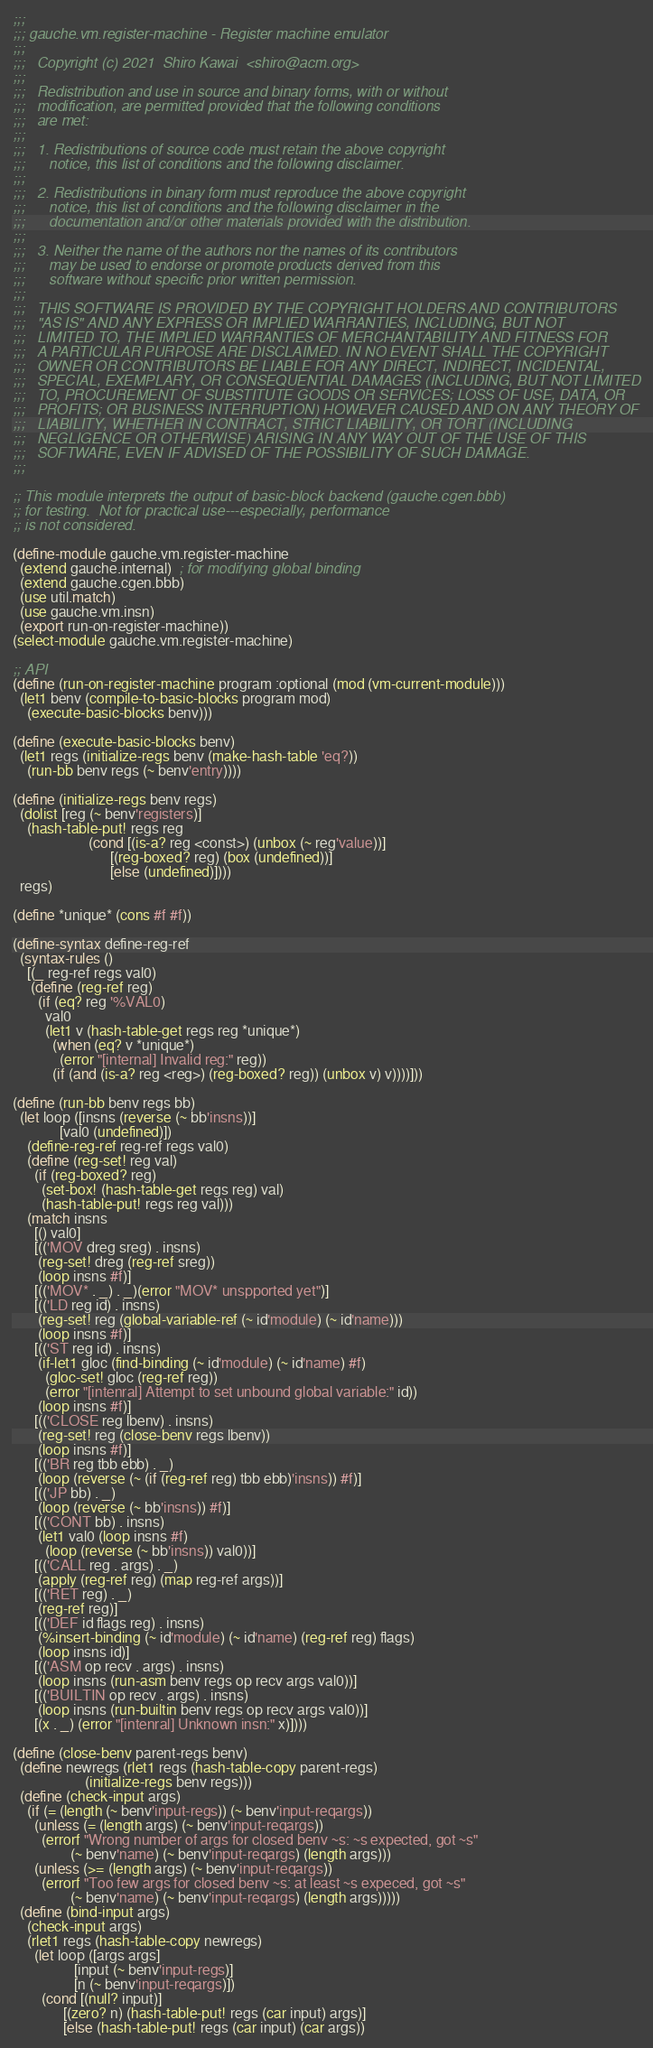<code> <loc_0><loc_0><loc_500><loc_500><_Scheme_>;;;
;;; gauche.vm.register-machine - Register machine emulator
;;;
;;;   Copyright (c) 2021  Shiro Kawai  <shiro@acm.org>
;;;
;;;   Redistribution and use in source and binary forms, with or without
;;;   modification, are permitted provided that the following conditions
;;;   are met:
;;;
;;;   1. Redistributions of source code must retain the above copyright
;;;      notice, this list of conditions and the following disclaimer.
;;;
;;;   2. Redistributions in binary form must reproduce the above copyright
;;;      notice, this list of conditions and the following disclaimer in the
;;;      documentation and/or other materials provided with the distribution.
;;;
;;;   3. Neither the name of the authors nor the names of its contributors
;;;      may be used to endorse or promote products derived from this
;;;      software without specific prior written permission.
;;;
;;;   THIS SOFTWARE IS PROVIDED BY THE COPYRIGHT HOLDERS AND CONTRIBUTORS
;;;   "AS IS" AND ANY EXPRESS OR IMPLIED WARRANTIES, INCLUDING, BUT NOT
;;;   LIMITED TO, THE IMPLIED WARRANTIES OF MERCHANTABILITY AND FITNESS FOR
;;;   A PARTICULAR PURPOSE ARE DISCLAIMED. IN NO EVENT SHALL THE COPYRIGHT
;;;   OWNER OR CONTRIBUTORS BE LIABLE FOR ANY DIRECT, INDIRECT, INCIDENTAL,
;;;   SPECIAL, EXEMPLARY, OR CONSEQUENTIAL DAMAGES (INCLUDING, BUT NOT LIMITED
;;;   TO, PROCUREMENT OF SUBSTITUTE GOODS OR SERVICES; LOSS OF USE, DATA, OR
;;;   PROFITS; OR BUSINESS INTERRUPTION) HOWEVER CAUSED AND ON ANY THEORY OF
;;;   LIABILITY, WHETHER IN CONTRACT, STRICT LIABILITY, OR TORT (INCLUDING
;;;   NEGLIGENCE OR OTHERWISE) ARISING IN ANY WAY OUT OF THE USE OF THIS
;;;   SOFTWARE, EVEN IF ADVISED OF THE POSSIBILITY OF SUCH DAMAGE.
;;;

;; This module interprets the output of basic-block backend (gauche.cgen.bbb)
;; for testing.  Not for practical use---especially, performance
;; is not considered.

(define-module gauche.vm.register-machine
  (extend gauche.internal)  ; for modifying global binding
  (extend gauche.cgen.bbb)
  (use util.match)
  (use gauche.vm.insn)
  (export run-on-register-machine))
(select-module gauche.vm.register-machine)

;; API
(define (run-on-register-machine program :optional (mod (vm-current-module)))
  (let1 benv (compile-to-basic-blocks program mod)
    (execute-basic-blocks benv)))

(define (execute-basic-blocks benv)
  (let1 regs (initialize-regs benv (make-hash-table 'eq?))
    (run-bb benv regs (~ benv'entry))))

(define (initialize-regs benv regs)
  (dolist [reg (~ benv'registers)]
    (hash-table-put! regs reg
                     (cond [(is-a? reg <const>) (unbox (~ reg'value))]
                           [(reg-boxed? reg) (box (undefined))]
                           [else (undefined)])))
  regs)

(define *unique* (cons #f #f))

(define-syntax define-reg-ref
  (syntax-rules ()
    [(_ reg-ref regs val0)
     (define (reg-ref reg)
       (if (eq? reg '%VAL0)
         val0
         (let1 v (hash-table-get regs reg *unique*)
           (when (eq? v *unique*)
             (error "[internal] Invalid reg:" reg))
           (if (and (is-a? reg <reg>) (reg-boxed? reg)) (unbox v) v))))]))

(define (run-bb benv regs bb)
  (let loop ([insns (reverse (~ bb'insns))]
             [val0 (undefined)])
    (define-reg-ref reg-ref regs val0)
    (define (reg-set! reg val)
      (if (reg-boxed? reg)
        (set-box! (hash-table-get regs reg) val)
        (hash-table-put! regs reg val)))
    (match insns
      [() val0]
      [(('MOV dreg sreg) . insns)
       (reg-set! dreg (reg-ref sreg))
       (loop insns #f)]
      [(('MOV* . _) . _)(error "MOV* unspported yet")]
      [(('LD reg id) . insns)
       (reg-set! reg (global-variable-ref (~ id'module) (~ id'name)))
       (loop insns #f)]
      [(('ST reg id) . insns)
       (if-let1 gloc (find-binding (~ id'module) (~ id'name) #f)
         (gloc-set! gloc (reg-ref reg))
         (error "[intenral] Attempt to set unbound global variable:" id))
       (loop insns #f)]
      [(('CLOSE reg lbenv) . insns)
       (reg-set! reg (close-benv regs lbenv))
       (loop insns #f)]
      [(('BR reg tbb ebb) . _)
       (loop (reverse (~ (if (reg-ref reg) tbb ebb)'insns)) #f)]
      [(('JP bb) . _)
       (loop (reverse (~ bb'insns)) #f)]
      [(('CONT bb) . insns)
       (let1 val0 (loop insns #f)
         (loop (reverse (~ bb'insns)) val0))]
      [(('CALL reg . args) . _)
       (apply (reg-ref reg) (map reg-ref args))]
      [(('RET reg) . _)
       (reg-ref reg)]
      [(('DEF id flags reg) . insns)
       (%insert-binding (~ id'module) (~ id'name) (reg-ref reg) flags)
       (loop insns id)]
      [(('ASM op recv . args) . insns)
       (loop insns (run-asm benv regs op recv args val0))]
      [(('BUILTIN op recv . args) . insns)
       (loop insns (run-builtin benv regs op recv args val0))]
      [(x . _) (error "[intenral] Unknown insn:" x)])))

(define (close-benv parent-regs benv)
  (define newregs (rlet1 regs (hash-table-copy parent-regs)
                    (initialize-regs benv regs)))
  (define (check-input args)
    (if (= (length (~ benv'input-regs)) (~ benv'input-reqargs))
      (unless (= (length args) (~ benv'input-reqargs))
        (errorf "Wrong number of args for closed benv ~s: ~s expected, got ~s"
                (~ benv'name) (~ benv'input-reqargs) (length args)))
      (unless (>= (length args) (~ benv'input-reqargs))
        (errorf "Too few args for closed benv ~s: at least ~s expeced, got ~s"
                (~ benv'name) (~ benv'input-reqargs) (length args)))))
  (define (bind-input args)
    (check-input args)
    (rlet1 regs (hash-table-copy newregs)
      (let loop ([args args]
                 [input (~ benv'input-regs)]
                 [n (~ benv'input-reqargs)])
        (cond [(null? input)]
              [(zero? n) (hash-table-put! regs (car input) args)]
              [else (hash-table-put! regs (car input) (car args))</code> 